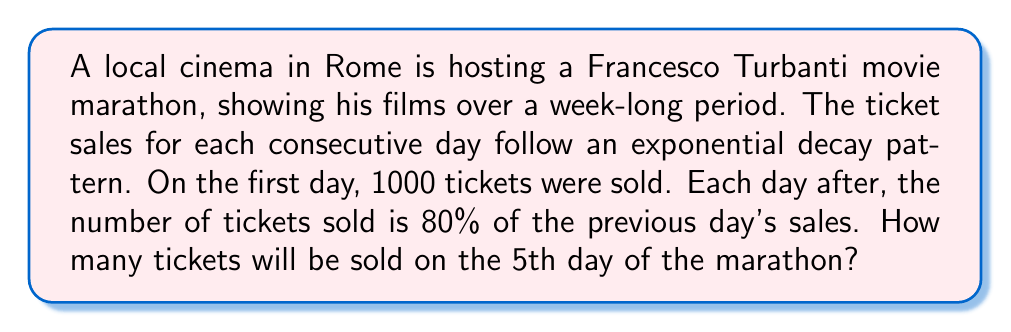Help me with this question. Let's approach this step-by-step:

1) We start with the initial number of tickets sold: $N_0 = 1000$

2) The decay rate is 80% or 0.8, which means each day the number of tickets sold is multiplied by 0.8

3) We can represent this using the exponential decay formula:

   $N(t) = N_0 \cdot r^t$

   Where:
   $N(t)$ is the number of tickets sold on day $t$
   $N_0$ is the initial number of tickets sold (1000)
   $r$ is the decay rate (0.8)
   $t$ is the number of days since the start (in this case, 4, as we're looking at the 5th day)

4) Plugging in our values:

   $N(4) = 1000 \cdot (0.8)^4$

5) Now let's calculate:

   $N(4) = 1000 \cdot (0.8)^4$
   $= 1000 \cdot 0.4096$
   $= 409.6$

6) Since we can't sell a fraction of a ticket, we round down to the nearest whole number.
Answer: On the 5th day of the Francesco Turbanti movie marathon, 409 tickets will be sold. 